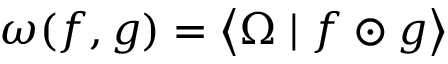<formula> <loc_0><loc_0><loc_500><loc_500>\omega ( f , g ) = \left \langle \Omega | f \odot g \right \rangle</formula> 